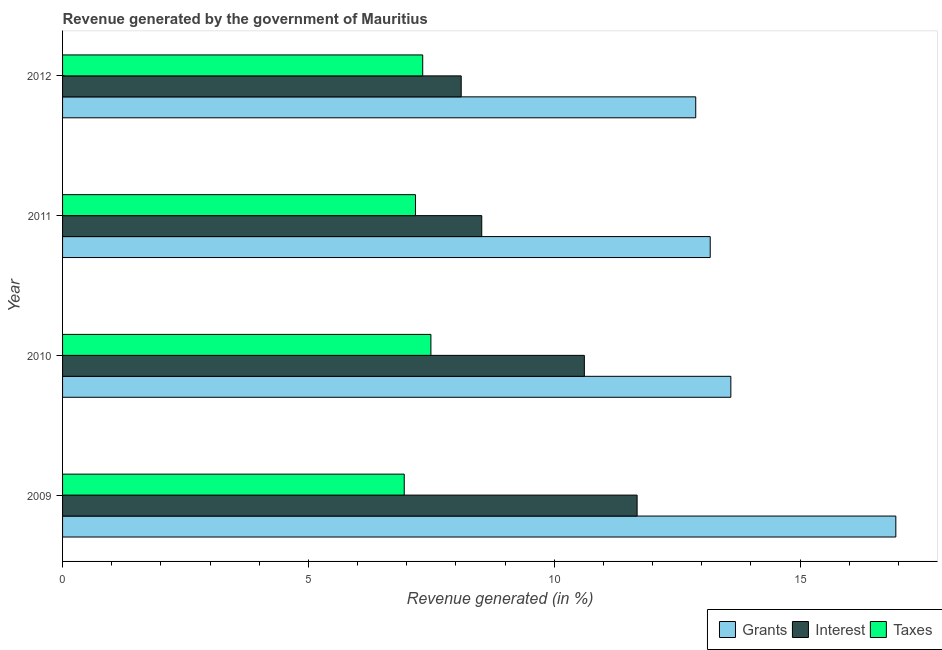Are the number of bars on each tick of the Y-axis equal?
Give a very brief answer. Yes. How many bars are there on the 2nd tick from the top?
Offer a terse response. 3. How many bars are there on the 1st tick from the bottom?
Your answer should be compact. 3. What is the label of the 2nd group of bars from the top?
Keep it short and to the point. 2011. In how many cases, is the number of bars for a given year not equal to the number of legend labels?
Make the answer very short. 0. What is the percentage of revenue generated by interest in 2011?
Keep it short and to the point. 8.53. Across all years, what is the maximum percentage of revenue generated by taxes?
Make the answer very short. 7.49. Across all years, what is the minimum percentage of revenue generated by interest?
Your answer should be compact. 8.11. In which year was the percentage of revenue generated by taxes maximum?
Offer a terse response. 2010. In which year was the percentage of revenue generated by taxes minimum?
Your answer should be very brief. 2009. What is the total percentage of revenue generated by interest in the graph?
Provide a succinct answer. 38.93. What is the difference between the percentage of revenue generated by taxes in 2009 and that in 2010?
Give a very brief answer. -0.54. What is the difference between the percentage of revenue generated by interest in 2011 and the percentage of revenue generated by taxes in 2012?
Your answer should be very brief. 1.2. What is the average percentage of revenue generated by grants per year?
Your answer should be very brief. 14.15. In the year 2009, what is the difference between the percentage of revenue generated by grants and percentage of revenue generated by interest?
Give a very brief answer. 5.26. What is the ratio of the percentage of revenue generated by interest in 2009 to that in 2012?
Your answer should be very brief. 1.44. Is the percentage of revenue generated by taxes in 2009 less than that in 2010?
Keep it short and to the point. Yes. Is the difference between the percentage of revenue generated by interest in 2009 and 2010 greater than the difference between the percentage of revenue generated by taxes in 2009 and 2010?
Your answer should be very brief. Yes. What is the difference between the highest and the second highest percentage of revenue generated by interest?
Keep it short and to the point. 1.07. What is the difference between the highest and the lowest percentage of revenue generated by grants?
Your answer should be very brief. 4.07. What does the 2nd bar from the top in 2010 represents?
Provide a short and direct response. Interest. What does the 2nd bar from the bottom in 2009 represents?
Your answer should be compact. Interest. Are all the bars in the graph horizontal?
Keep it short and to the point. Yes. Does the graph contain any zero values?
Ensure brevity in your answer.  No. Does the graph contain grids?
Offer a terse response. No. Where does the legend appear in the graph?
Give a very brief answer. Bottom right. What is the title of the graph?
Your answer should be very brief. Revenue generated by the government of Mauritius. Does "Unpaid family workers" appear as one of the legend labels in the graph?
Give a very brief answer. No. What is the label or title of the X-axis?
Ensure brevity in your answer.  Revenue generated (in %). What is the Revenue generated (in %) in Grants in 2009?
Keep it short and to the point. 16.95. What is the Revenue generated (in %) in Interest in 2009?
Your answer should be compact. 11.68. What is the Revenue generated (in %) in Taxes in 2009?
Ensure brevity in your answer.  6.95. What is the Revenue generated (in %) of Grants in 2010?
Keep it short and to the point. 13.59. What is the Revenue generated (in %) of Interest in 2010?
Keep it short and to the point. 10.61. What is the Revenue generated (in %) in Taxes in 2010?
Give a very brief answer. 7.49. What is the Revenue generated (in %) in Grants in 2011?
Ensure brevity in your answer.  13.17. What is the Revenue generated (in %) in Interest in 2011?
Make the answer very short. 8.53. What is the Revenue generated (in %) in Taxes in 2011?
Your response must be concise. 7.18. What is the Revenue generated (in %) in Grants in 2012?
Your answer should be very brief. 12.88. What is the Revenue generated (in %) of Interest in 2012?
Make the answer very short. 8.11. What is the Revenue generated (in %) of Taxes in 2012?
Make the answer very short. 7.32. Across all years, what is the maximum Revenue generated (in %) of Grants?
Provide a short and direct response. 16.95. Across all years, what is the maximum Revenue generated (in %) in Interest?
Provide a succinct answer. 11.68. Across all years, what is the maximum Revenue generated (in %) in Taxes?
Offer a terse response. 7.49. Across all years, what is the minimum Revenue generated (in %) in Grants?
Make the answer very short. 12.88. Across all years, what is the minimum Revenue generated (in %) of Interest?
Provide a succinct answer. 8.11. Across all years, what is the minimum Revenue generated (in %) of Taxes?
Provide a short and direct response. 6.95. What is the total Revenue generated (in %) of Grants in the graph?
Your answer should be very brief. 56.59. What is the total Revenue generated (in %) of Interest in the graph?
Your answer should be very brief. 38.93. What is the total Revenue generated (in %) of Taxes in the graph?
Your answer should be very brief. 28.94. What is the difference between the Revenue generated (in %) in Grants in 2009 and that in 2010?
Ensure brevity in your answer.  3.36. What is the difference between the Revenue generated (in %) in Interest in 2009 and that in 2010?
Offer a very short reply. 1.07. What is the difference between the Revenue generated (in %) of Taxes in 2009 and that in 2010?
Your answer should be compact. -0.54. What is the difference between the Revenue generated (in %) in Grants in 2009 and that in 2011?
Ensure brevity in your answer.  3.77. What is the difference between the Revenue generated (in %) in Interest in 2009 and that in 2011?
Your answer should be very brief. 3.16. What is the difference between the Revenue generated (in %) in Taxes in 2009 and that in 2011?
Provide a short and direct response. -0.23. What is the difference between the Revenue generated (in %) of Grants in 2009 and that in 2012?
Provide a short and direct response. 4.07. What is the difference between the Revenue generated (in %) in Interest in 2009 and that in 2012?
Ensure brevity in your answer.  3.58. What is the difference between the Revenue generated (in %) of Taxes in 2009 and that in 2012?
Offer a terse response. -0.38. What is the difference between the Revenue generated (in %) of Grants in 2010 and that in 2011?
Offer a very short reply. 0.42. What is the difference between the Revenue generated (in %) in Interest in 2010 and that in 2011?
Ensure brevity in your answer.  2.09. What is the difference between the Revenue generated (in %) of Taxes in 2010 and that in 2011?
Your response must be concise. 0.31. What is the difference between the Revenue generated (in %) in Grants in 2010 and that in 2012?
Give a very brief answer. 0.71. What is the difference between the Revenue generated (in %) of Interest in 2010 and that in 2012?
Keep it short and to the point. 2.5. What is the difference between the Revenue generated (in %) in Taxes in 2010 and that in 2012?
Keep it short and to the point. 0.17. What is the difference between the Revenue generated (in %) of Grants in 2011 and that in 2012?
Provide a succinct answer. 0.29. What is the difference between the Revenue generated (in %) in Interest in 2011 and that in 2012?
Provide a short and direct response. 0.42. What is the difference between the Revenue generated (in %) of Taxes in 2011 and that in 2012?
Your answer should be compact. -0.15. What is the difference between the Revenue generated (in %) in Grants in 2009 and the Revenue generated (in %) in Interest in 2010?
Make the answer very short. 6.33. What is the difference between the Revenue generated (in %) in Grants in 2009 and the Revenue generated (in %) in Taxes in 2010?
Offer a very short reply. 9.46. What is the difference between the Revenue generated (in %) in Interest in 2009 and the Revenue generated (in %) in Taxes in 2010?
Make the answer very short. 4.19. What is the difference between the Revenue generated (in %) in Grants in 2009 and the Revenue generated (in %) in Interest in 2011?
Offer a terse response. 8.42. What is the difference between the Revenue generated (in %) in Grants in 2009 and the Revenue generated (in %) in Taxes in 2011?
Offer a very short reply. 9.77. What is the difference between the Revenue generated (in %) in Interest in 2009 and the Revenue generated (in %) in Taxes in 2011?
Provide a succinct answer. 4.51. What is the difference between the Revenue generated (in %) in Grants in 2009 and the Revenue generated (in %) in Interest in 2012?
Provide a succinct answer. 8.84. What is the difference between the Revenue generated (in %) of Grants in 2009 and the Revenue generated (in %) of Taxes in 2012?
Your answer should be very brief. 9.62. What is the difference between the Revenue generated (in %) of Interest in 2009 and the Revenue generated (in %) of Taxes in 2012?
Make the answer very short. 4.36. What is the difference between the Revenue generated (in %) in Grants in 2010 and the Revenue generated (in %) in Interest in 2011?
Offer a terse response. 5.07. What is the difference between the Revenue generated (in %) in Grants in 2010 and the Revenue generated (in %) in Taxes in 2011?
Offer a very short reply. 6.41. What is the difference between the Revenue generated (in %) of Interest in 2010 and the Revenue generated (in %) of Taxes in 2011?
Keep it short and to the point. 3.43. What is the difference between the Revenue generated (in %) of Grants in 2010 and the Revenue generated (in %) of Interest in 2012?
Provide a short and direct response. 5.48. What is the difference between the Revenue generated (in %) of Grants in 2010 and the Revenue generated (in %) of Taxes in 2012?
Your answer should be compact. 6.27. What is the difference between the Revenue generated (in %) of Interest in 2010 and the Revenue generated (in %) of Taxes in 2012?
Provide a short and direct response. 3.29. What is the difference between the Revenue generated (in %) in Grants in 2011 and the Revenue generated (in %) in Interest in 2012?
Give a very brief answer. 5.06. What is the difference between the Revenue generated (in %) in Grants in 2011 and the Revenue generated (in %) in Taxes in 2012?
Your answer should be compact. 5.85. What is the difference between the Revenue generated (in %) in Interest in 2011 and the Revenue generated (in %) in Taxes in 2012?
Ensure brevity in your answer.  1.2. What is the average Revenue generated (in %) in Grants per year?
Your response must be concise. 14.15. What is the average Revenue generated (in %) in Interest per year?
Keep it short and to the point. 9.73. What is the average Revenue generated (in %) of Taxes per year?
Make the answer very short. 7.24. In the year 2009, what is the difference between the Revenue generated (in %) in Grants and Revenue generated (in %) in Interest?
Your answer should be compact. 5.26. In the year 2009, what is the difference between the Revenue generated (in %) in Grants and Revenue generated (in %) in Taxes?
Your answer should be compact. 10. In the year 2009, what is the difference between the Revenue generated (in %) in Interest and Revenue generated (in %) in Taxes?
Give a very brief answer. 4.74. In the year 2010, what is the difference between the Revenue generated (in %) in Grants and Revenue generated (in %) in Interest?
Provide a short and direct response. 2.98. In the year 2010, what is the difference between the Revenue generated (in %) of Grants and Revenue generated (in %) of Taxes?
Make the answer very short. 6.1. In the year 2010, what is the difference between the Revenue generated (in %) in Interest and Revenue generated (in %) in Taxes?
Your answer should be very brief. 3.12. In the year 2011, what is the difference between the Revenue generated (in %) in Grants and Revenue generated (in %) in Interest?
Offer a very short reply. 4.65. In the year 2011, what is the difference between the Revenue generated (in %) in Grants and Revenue generated (in %) in Taxes?
Give a very brief answer. 5.99. In the year 2011, what is the difference between the Revenue generated (in %) of Interest and Revenue generated (in %) of Taxes?
Offer a terse response. 1.35. In the year 2012, what is the difference between the Revenue generated (in %) of Grants and Revenue generated (in %) of Interest?
Give a very brief answer. 4.77. In the year 2012, what is the difference between the Revenue generated (in %) of Grants and Revenue generated (in %) of Taxes?
Give a very brief answer. 5.55. In the year 2012, what is the difference between the Revenue generated (in %) in Interest and Revenue generated (in %) in Taxes?
Your answer should be compact. 0.78. What is the ratio of the Revenue generated (in %) in Grants in 2009 to that in 2010?
Give a very brief answer. 1.25. What is the ratio of the Revenue generated (in %) of Interest in 2009 to that in 2010?
Provide a succinct answer. 1.1. What is the ratio of the Revenue generated (in %) in Taxes in 2009 to that in 2010?
Offer a terse response. 0.93. What is the ratio of the Revenue generated (in %) of Grants in 2009 to that in 2011?
Provide a succinct answer. 1.29. What is the ratio of the Revenue generated (in %) of Interest in 2009 to that in 2011?
Provide a succinct answer. 1.37. What is the ratio of the Revenue generated (in %) in Taxes in 2009 to that in 2011?
Your answer should be very brief. 0.97. What is the ratio of the Revenue generated (in %) of Grants in 2009 to that in 2012?
Ensure brevity in your answer.  1.32. What is the ratio of the Revenue generated (in %) in Interest in 2009 to that in 2012?
Your answer should be compact. 1.44. What is the ratio of the Revenue generated (in %) in Taxes in 2009 to that in 2012?
Offer a terse response. 0.95. What is the ratio of the Revenue generated (in %) of Grants in 2010 to that in 2011?
Offer a terse response. 1.03. What is the ratio of the Revenue generated (in %) in Interest in 2010 to that in 2011?
Provide a short and direct response. 1.24. What is the ratio of the Revenue generated (in %) in Taxes in 2010 to that in 2011?
Your answer should be very brief. 1.04. What is the ratio of the Revenue generated (in %) in Grants in 2010 to that in 2012?
Ensure brevity in your answer.  1.06. What is the ratio of the Revenue generated (in %) in Interest in 2010 to that in 2012?
Provide a succinct answer. 1.31. What is the ratio of the Revenue generated (in %) in Taxes in 2010 to that in 2012?
Offer a very short reply. 1.02. What is the ratio of the Revenue generated (in %) of Grants in 2011 to that in 2012?
Provide a succinct answer. 1.02. What is the ratio of the Revenue generated (in %) of Interest in 2011 to that in 2012?
Your response must be concise. 1.05. What is the ratio of the Revenue generated (in %) of Taxes in 2011 to that in 2012?
Ensure brevity in your answer.  0.98. What is the difference between the highest and the second highest Revenue generated (in %) of Grants?
Make the answer very short. 3.36. What is the difference between the highest and the second highest Revenue generated (in %) in Interest?
Keep it short and to the point. 1.07. What is the difference between the highest and the second highest Revenue generated (in %) of Taxes?
Offer a terse response. 0.17. What is the difference between the highest and the lowest Revenue generated (in %) of Grants?
Your answer should be compact. 4.07. What is the difference between the highest and the lowest Revenue generated (in %) in Interest?
Make the answer very short. 3.58. What is the difference between the highest and the lowest Revenue generated (in %) of Taxes?
Offer a terse response. 0.54. 